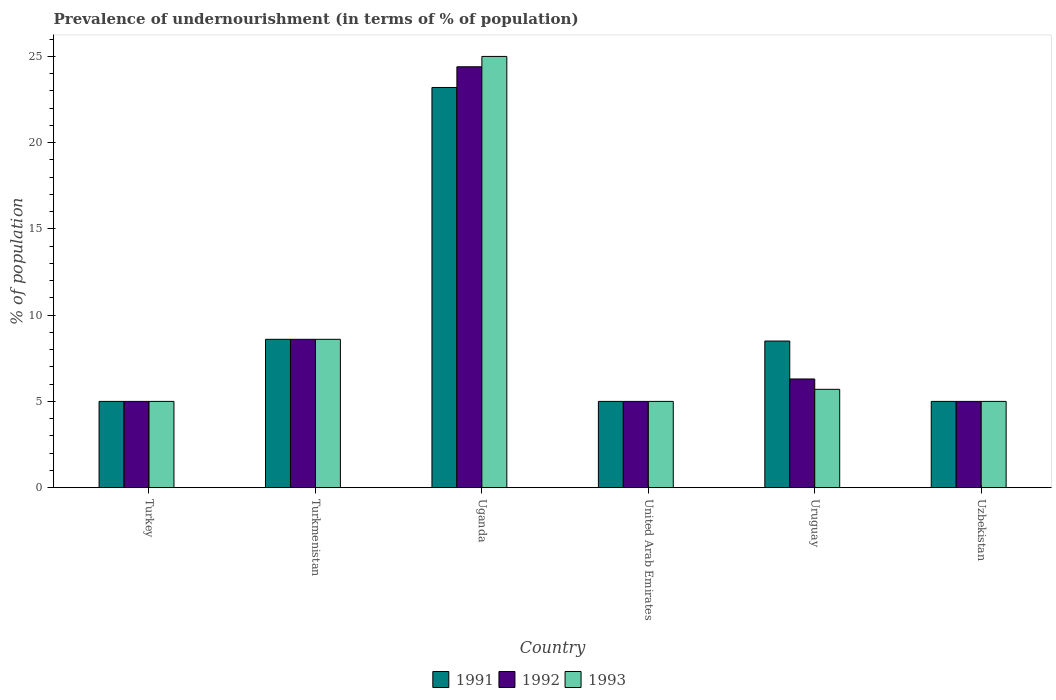How many different coloured bars are there?
Your answer should be very brief. 3. How many groups of bars are there?
Give a very brief answer. 6. Are the number of bars per tick equal to the number of legend labels?
Make the answer very short. Yes. What is the label of the 2nd group of bars from the left?
Provide a short and direct response. Turkmenistan. What is the percentage of undernourished population in 1993 in Turkey?
Your response must be concise. 5. Across all countries, what is the maximum percentage of undernourished population in 1993?
Make the answer very short. 25. In which country was the percentage of undernourished population in 1991 maximum?
Offer a terse response. Uganda. What is the total percentage of undernourished population in 1991 in the graph?
Offer a terse response. 55.3. What is the difference between the percentage of undernourished population in 1991 in Uruguay and that in Uzbekistan?
Offer a very short reply. 3.5. What is the difference between the percentage of undernourished population in 1992 in Uganda and the percentage of undernourished population in 1993 in Turkmenistan?
Make the answer very short. 15.8. What is the average percentage of undernourished population in 1991 per country?
Provide a succinct answer. 9.22. In how many countries, is the percentage of undernourished population in 1993 greater than 24 %?
Your answer should be very brief. 1. What is the ratio of the percentage of undernourished population in 1991 in Turkmenistan to that in Uganda?
Your response must be concise. 0.37. Is the difference between the percentage of undernourished population in 1991 in United Arab Emirates and Uruguay greater than the difference between the percentage of undernourished population in 1992 in United Arab Emirates and Uruguay?
Give a very brief answer. No. What is the difference between the highest and the second highest percentage of undernourished population in 1993?
Offer a terse response. -16.4. What is the difference between the highest and the lowest percentage of undernourished population in 1992?
Keep it short and to the point. 19.4. In how many countries, is the percentage of undernourished population in 1992 greater than the average percentage of undernourished population in 1992 taken over all countries?
Provide a succinct answer. 1. Is the sum of the percentage of undernourished population in 1991 in Turkmenistan and Uzbekistan greater than the maximum percentage of undernourished population in 1993 across all countries?
Provide a short and direct response. No. What does the 3rd bar from the left in United Arab Emirates represents?
Ensure brevity in your answer.  1993. Is it the case that in every country, the sum of the percentage of undernourished population in 1993 and percentage of undernourished population in 1992 is greater than the percentage of undernourished population in 1991?
Offer a very short reply. Yes. Are all the bars in the graph horizontal?
Make the answer very short. No. How many countries are there in the graph?
Your answer should be compact. 6. Are the values on the major ticks of Y-axis written in scientific E-notation?
Offer a terse response. No. Does the graph contain any zero values?
Your answer should be very brief. No. Does the graph contain grids?
Offer a very short reply. No. Where does the legend appear in the graph?
Provide a succinct answer. Bottom center. How are the legend labels stacked?
Provide a short and direct response. Horizontal. What is the title of the graph?
Provide a succinct answer. Prevalence of undernourishment (in terms of % of population). Does "1970" appear as one of the legend labels in the graph?
Make the answer very short. No. What is the label or title of the X-axis?
Give a very brief answer. Country. What is the label or title of the Y-axis?
Make the answer very short. % of population. What is the % of population in 1991 in Turkey?
Your answer should be compact. 5. What is the % of population in 1992 in Turkey?
Your answer should be very brief. 5. What is the % of population of 1991 in Turkmenistan?
Give a very brief answer. 8.6. What is the % of population in 1992 in Turkmenistan?
Offer a terse response. 8.6. What is the % of population of 1993 in Turkmenistan?
Ensure brevity in your answer.  8.6. What is the % of population of 1991 in Uganda?
Your answer should be compact. 23.2. What is the % of population in 1992 in Uganda?
Your answer should be very brief. 24.4. What is the % of population in 1993 in Uganda?
Your answer should be compact. 25. What is the % of population in 1991 in United Arab Emirates?
Provide a short and direct response. 5. What is the % of population in 1992 in United Arab Emirates?
Your answer should be very brief. 5. What is the % of population of 1993 in Uruguay?
Offer a very short reply. 5.7. What is the % of population of 1991 in Uzbekistan?
Provide a succinct answer. 5. What is the % of population of 1992 in Uzbekistan?
Ensure brevity in your answer.  5. What is the % of population in 1993 in Uzbekistan?
Provide a short and direct response. 5. Across all countries, what is the maximum % of population of 1991?
Your answer should be compact. 23.2. Across all countries, what is the maximum % of population of 1992?
Ensure brevity in your answer.  24.4. Across all countries, what is the minimum % of population in 1993?
Your answer should be compact. 5. What is the total % of population in 1991 in the graph?
Keep it short and to the point. 55.3. What is the total % of population in 1992 in the graph?
Keep it short and to the point. 54.3. What is the total % of population in 1993 in the graph?
Your answer should be very brief. 54.3. What is the difference between the % of population in 1991 in Turkey and that in Uganda?
Your answer should be compact. -18.2. What is the difference between the % of population of 1992 in Turkey and that in Uganda?
Offer a very short reply. -19.4. What is the difference between the % of population in 1991 in Turkey and that in United Arab Emirates?
Make the answer very short. 0. What is the difference between the % of population in 1992 in Turkey and that in United Arab Emirates?
Offer a very short reply. 0. What is the difference between the % of population of 1991 in Turkey and that in Uruguay?
Give a very brief answer. -3.5. What is the difference between the % of population in 1993 in Turkey and that in Uruguay?
Give a very brief answer. -0.7. What is the difference between the % of population in 1992 in Turkey and that in Uzbekistan?
Your answer should be compact. 0. What is the difference between the % of population of 1991 in Turkmenistan and that in Uganda?
Keep it short and to the point. -14.6. What is the difference between the % of population in 1992 in Turkmenistan and that in Uganda?
Your response must be concise. -15.8. What is the difference between the % of population in 1993 in Turkmenistan and that in Uganda?
Your answer should be compact. -16.4. What is the difference between the % of population of 1991 in Turkmenistan and that in United Arab Emirates?
Provide a short and direct response. 3.6. What is the difference between the % of population of 1993 in Turkmenistan and that in Uruguay?
Your answer should be very brief. 2.9. What is the difference between the % of population of 1991 in Turkmenistan and that in Uzbekistan?
Give a very brief answer. 3.6. What is the difference between the % of population in 1992 in Turkmenistan and that in Uzbekistan?
Make the answer very short. 3.6. What is the difference between the % of population in 1993 in Turkmenistan and that in Uzbekistan?
Make the answer very short. 3.6. What is the difference between the % of population in 1991 in Uganda and that in United Arab Emirates?
Give a very brief answer. 18.2. What is the difference between the % of population in 1991 in Uganda and that in Uruguay?
Give a very brief answer. 14.7. What is the difference between the % of population in 1992 in Uganda and that in Uruguay?
Your response must be concise. 18.1. What is the difference between the % of population in 1993 in Uganda and that in Uruguay?
Your response must be concise. 19.3. What is the difference between the % of population of 1991 in United Arab Emirates and that in Uruguay?
Offer a very short reply. -3.5. What is the difference between the % of population in 1993 in United Arab Emirates and that in Uruguay?
Provide a succinct answer. -0.7. What is the difference between the % of population in 1991 in United Arab Emirates and that in Uzbekistan?
Provide a short and direct response. 0. What is the difference between the % of population of 1993 in United Arab Emirates and that in Uzbekistan?
Provide a succinct answer. 0. What is the difference between the % of population in 1991 in Uruguay and that in Uzbekistan?
Provide a short and direct response. 3.5. What is the difference between the % of population of 1992 in Uruguay and that in Uzbekistan?
Keep it short and to the point. 1.3. What is the difference between the % of population in 1991 in Turkey and the % of population in 1992 in Uganda?
Provide a short and direct response. -19.4. What is the difference between the % of population in 1991 in Turkey and the % of population in 1992 in United Arab Emirates?
Your answer should be very brief. 0. What is the difference between the % of population of 1991 in Turkey and the % of population of 1993 in United Arab Emirates?
Give a very brief answer. 0. What is the difference between the % of population of 1991 in Turkey and the % of population of 1992 in Uruguay?
Your answer should be very brief. -1.3. What is the difference between the % of population of 1991 in Turkey and the % of population of 1993 in Uruguay?
Your response must be concise. -0.7. What is the difference between the % of population in 1991 in Turkey and the % of population in 1993 in Uzbekistan?
Ensure brevity in your answer.  0. What is the difference between the % of population of 1991 in Turkmenistan and the % of population of 1992 in Uganda?
Give a very brief answer. -15.8. What is the difference between the % of population of 1991 in Turkmenistan and the % of population of 1993 in Uganda?
Ensure brevity in your answer.  -16.4. What is the difference between the % of population of 1992 in Turkmenistan and the % of population of 1993 in Uganda?
Provide a short and direct response. -16.4. What is the difference between the % of population of 1991 in Turkmenistan and the % of population of 1993 in United Arab Emirates?
Your response must be concise. 3.6. What is the difference between the % of population of 1992 in Turkmenistan and the % of population of 1993 in United Arab Emirates?
Give a very brief answer. 3.6. What is the difference between the % of population of 1991 in Turkmenistan and the % of population of 1992 in Uruguay?
Provide a short and direct response. 2.3. What is the difference between the % of population of 1991 in Turkmenistan and the % of population of 1992 in Uzbekistan?
Offer a very short reply. 3.6. What is the difference between the % of population of 1991 in Turkmenistan and the % of population of 1993 in Uzbekistan?
Ensure brevity in your answer.  3.6. What is the difference between the % of population in 1991 in Uganda and the % of population in 1993 in United Arab Emirates?
Your response must be concise. 18.2. What is the difference between the % of population in 1992 in Uganda and the % of population in 1993 in United Arab Emirates?
Your answer should be very brief. 19.4. What is the difference between the % of population in 1991 in Uganda and the % of population in 1992 in Uruguay?
Give a very brief answer. 16.9. What is the difference between the % of population of 1991 in Uganda and the % of population of 1993 in Uruguay?
Ensure brevity in your answer.  17.5. What is the difference between the % of population in 1992 in Uganda and the % of population in 1993 in Uruguay?
Keep it short and to the point. 18.7. What is the difference between the % of population in 1991 in United Arab Emirates and the % of population in 1993 in Uzbekistan?
Provide a succinct answer. 0. What is the difference between the % of population of 1991 in Uruguay and the % of population of 1992 in Uzbekistan?
Provide a short and direct response. 3.5. What is the difference between the % of population in 1992 in Uruguay and the % of population in 1993 in Uzbekistan?
Offer a terse response. 1.3. What is the average % of population in 1991 per country?
Offer a very short reply. 9.22. What is the average % of population in 1992 per country?
Your response must be concise. 9.05. What is the average % of population in 1993 per country?
Your response must be concise. 9.05. What is the difference between the % of population of 1991 and % of population of 1993 in Turkey?
Ensure brevity in your answer.  0. What is the difference between the % of population of 1991 and % of population of 1992 in Uganda?
Provide a succinct answer. -1.2. What is the difference between the % of population in 1991 and % of population in 1993 in Uganda?
Offer a very short reply. -1.8. What is the difference between the % of population in 1992 and % of population in 1993 in Uganda?
Give a very brief answer. -0.6. What is the difference between the % of population of 1991 and % of population of 1993 in United Arab Emirates?
Offer a very short reply. 0. What is the difference between the % of population of 1992 and % of population of 1993 in United Arab Emirates?
Ensure brevity in your answer.  0. What is the difference between the % of population in 1991 and % of population in 1992 in Uruguay?
Your answer should be very brief. 2.2. What is the difference between the % of population in 1991 and % of population in 1993 in Uruguay?
Your answer should be very brief. 2.8. What is the difference between the % of population in 1992 and % of population in 1993 in Uruguay?
Give a very brief answer. 0.6. What is the difference between the % of population of 1991 and % of population of 1992 in Uzbekistan?
Offer a terse response. 0. What is the difference between the % of population of 1991 and % of population of 1993 in Uzbekistan?
Keep it short and to the point. 0. What is the ratio of the % of population in 1991 in Turkey to that in Turkmenistan?
Your response must be concise. 0.58. What is the ratio of the % of population of 1992 in Turkey to that in Turkmenistan?
Provide a succinct answer. 0.58. What is the ratio of the % of population in 1993 in Turkey to that in Turkmenistan?
Your answer should be compact. 0.58. What is the ratio of the % of population of 1991 in Turkey to that in Uganda?
Your answer should be compact. 0.22. What is the ratio of the % of population of 1992 in Turkey to that in Uganda?
Keep it short and to the point. 0.2. What is the ratio of the % of population in 1993 in Turkey to that in Uganda?
Offer a very short reply. 0.2. What is the ratio of the % of population of 1993 in Turkey to that in United Arab Emirates?
Your response must be concise. 1. What is the ratio of the % of population of 1991 in Turkey to that in Uruguay?
Your answer should be very brief. 0.59. What is the ratio of the % of population in 1992 in Turkey to that in Uruguay?
Your answer should be very brief. 0.79. What is the ratio of the % of population in 1993 in Turkey to that in Uruguay?
Ensure brevity in your answer.  0.88. What is the ratio of the % of population of 1991 in Turkey to that in Uzbekistan?
Provide a short and direct response. 1. What is the ratio of the % of population in 1991 in Turkmenistan to that in Uganda?
Keep it short and to the point. 0.37. What is the ratio of the % of population of 1992 in Turkmenistan to that in Uganda?
Ensure brevity in your answer.  0.35. What is the ratio of the % of population in 1993 in Turkmenistan to that in Uganda?
Your response must be concise. 0.34. What is the ratio of the % of population of 1991 in Turkmenistan to that in United Arab Emirates?
Ensure brevity in your answer.  1.72. What is the ratio of the % of population in 1992 in Turkmenistan to that in United Arab Emirates?
Your answer should be compact. 1.72. What is the ratio of the % of population of 1993 in Turkmenistan to that in United Arab Emirates?
Your answer should be compact. 1.72. What is the ratio of the % of population in 1991 in Turkmenistan to that in Uruguay?
Provide a succinct answer. 1.01. What is the ratio of the % of population in 1992 in Turkmenistan to that in Uruguay?
Offer a terse response. 1.37. What is the ratio of the % of population of 1993 in Turkmenistan to that in Uruguay?
Your answer should be compact. 1.51. What is the ratio of the % of population of 1991 in Turkmenistan to that in Uzbekistan?
Give a very brief answer. 1.72. What is the ratio of the % of population of 1992 in Turkmenistan to that in Uzbekistan?
Your response must be concise. 1.72. What is the ratio of the % of population of 1993 in Turkmenistan to that in Uzbekistan?
Offer a terse response. 1.72. What is the ratio of the % of population of 1991 in Uganda to that in United Arab Emirates?
Give a very brief answer. 4.64. What is the ratio of the % of population in 1992 in Uganda to that in United Arab Emirates?
Keep it short and to the point. 4.88. What is the ratio of the % of population in 1993 in Uganda to that in United Arab Emirates?
Your response must be concise. 5. What is the ratio of the % of population of 1991 in Uganda to that in Uruguay?
Provide a succinct answer. 2.73. What is the ratio of the % of population in 1992 in Uganda to that in Uruguay?
Offer a very short reply. 3.87. What is the ratio of the % of population of 1993 in Uganda to that in Uruguay?
Your answer should be compact. 4.39. What is the ratio of the % of population in 1991 in Uganda to that in Uzbekistan?
Keep it short and to the point. 4.64. What is the ratio of the % of population in 1992 in Uganda to that in Uzbekistan?
Your response must be concise. 4.88. What is the ratio of the % of population of 1991 in United Arab Emirates to that in Uruguay?
Your answer should be compact. 0.59. What is the ratio of the % of population in 1992 in United Arab Emirates to that in Uruguay?
Give a very brief answer. 0.79. What is the ratio of the % of population in 1993 in United Arab Emirates to that in Uruguay?
Give a very brief answer. 0.88. What is the ratio of the % of population of 1991 in United Arab Emirates to that in Uzbekistan?
Your response must be concise. 1. What is the ratio of the % of population of 1993 in United Arab Emirates to that in Uzbekistan?
Your answer should be very brief. 1. What is the ratio of the % of population in 1991 in Uruguay to that in Uzbekistan?
Offer a very short reply. 1.7. What is the ratio of the % of population of 1992 in Uruguay to that in Uzbekistan?
Your answer should be compact. 1.26. What is the ratio of the % of population in 1993 in Uruguay to that in Uzbekistan?
Provide a short and direct response. 1.14. What is the difference between the highest and the second highest % of population in 1991?
Keep it short and to the point. 14.6. What is the difference between the highest and the second highest % of population in 1993?
Provide a succinct answer. 16.4. 